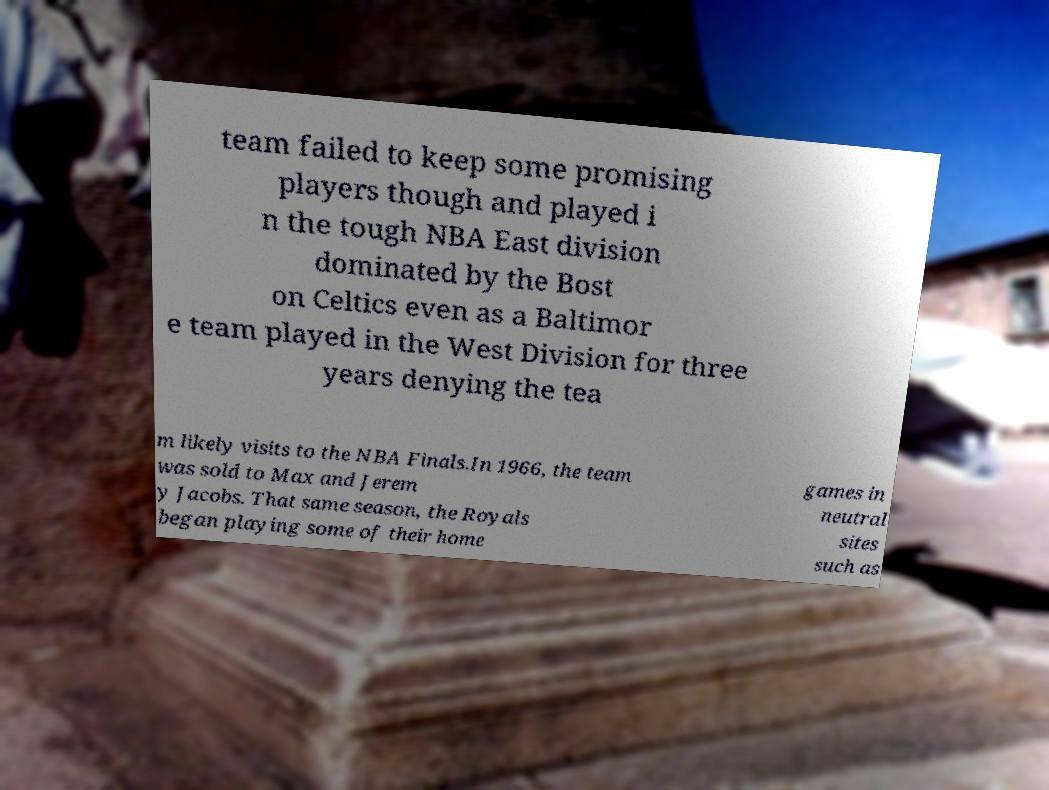Please read and relay the text visible in this image. What does it say? team failed to keep some promising players though and played i n the tough NBA East division dominated by the Bost on Celtics even as a Baltimor e team played in the West Division for three years denying the tea m likely visits to the NBA Finals.In 1966, the team was sold to Max and Jerem y Jacobs. That same season, the Royals began playing some of their home games in neutral sites such as 